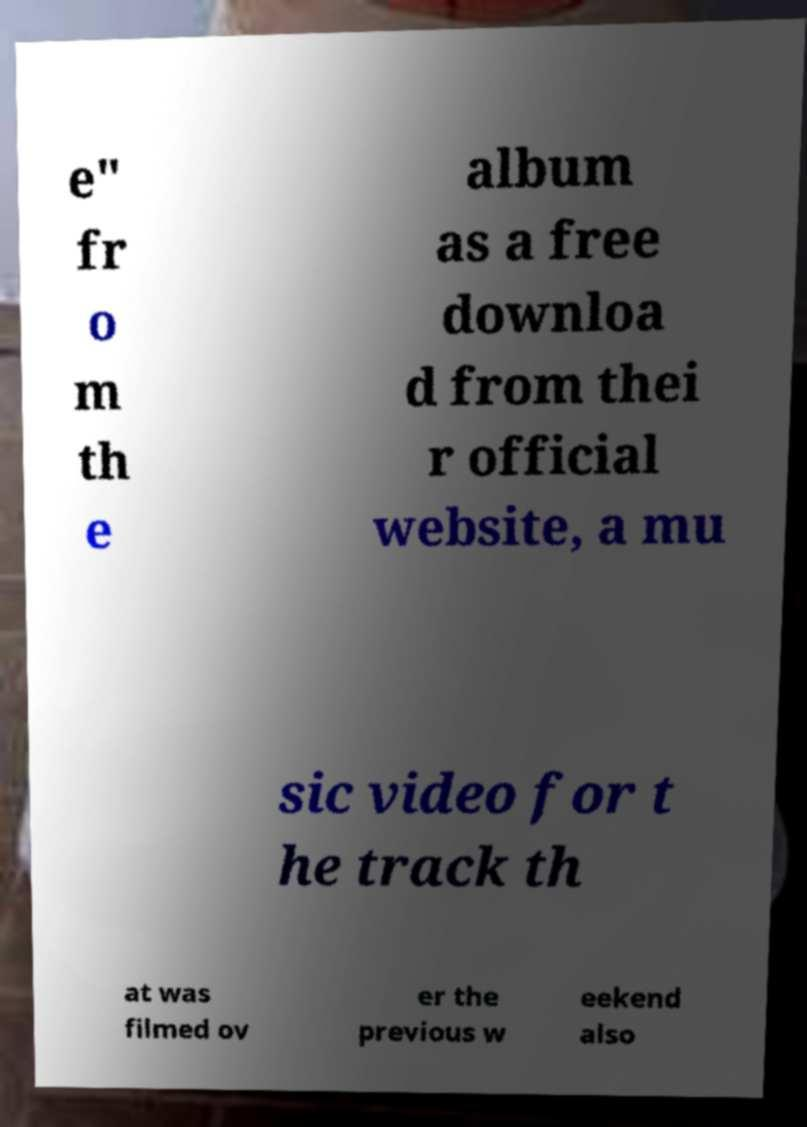For documentation purposes, I need the text within this image transcribed. Could you provide that? e" fr o m th e album as a free downloa d from thei r official website, a mu sic video for t he track th at was filmed ov er the previous w eekend also 